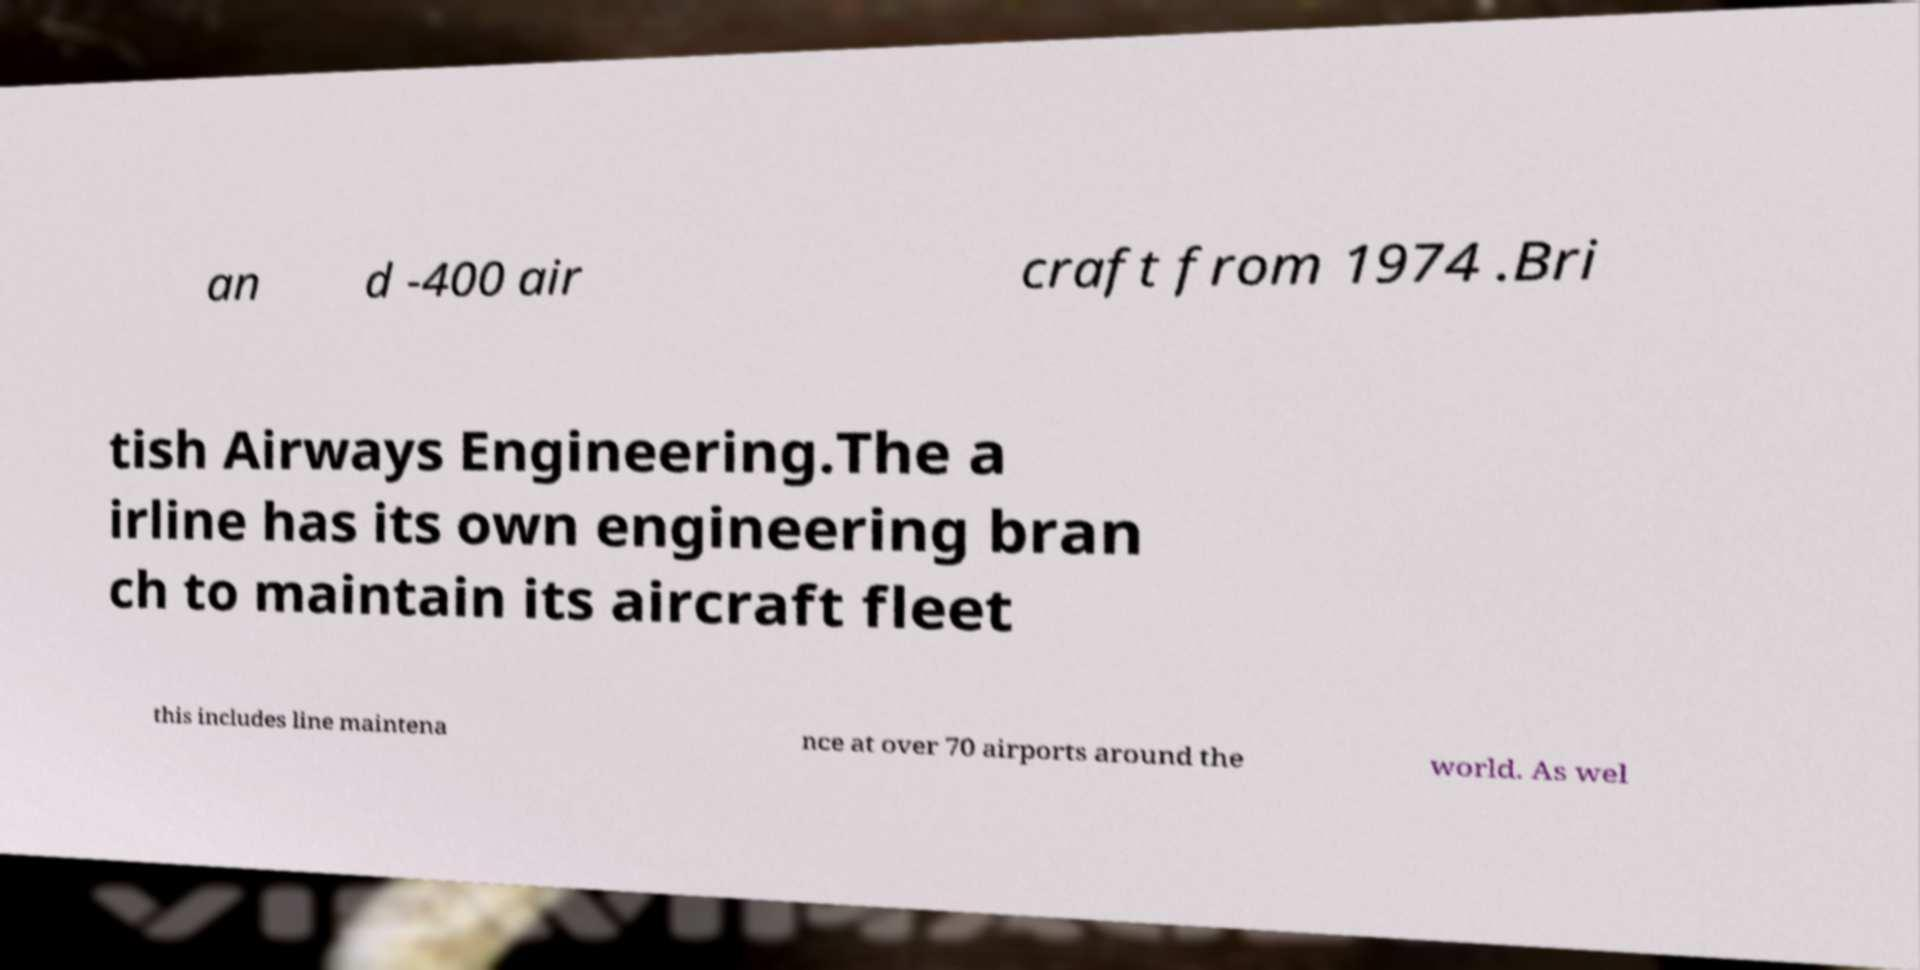Please identify and transcribe the text found in this image. an d -400 air craft from 1974 .Bri tish Airways Engineering.The a irline has its own engineering bran ch to maintain its aircraft fleet this includes line maintena nce at over 70 airports around the world. As wel 